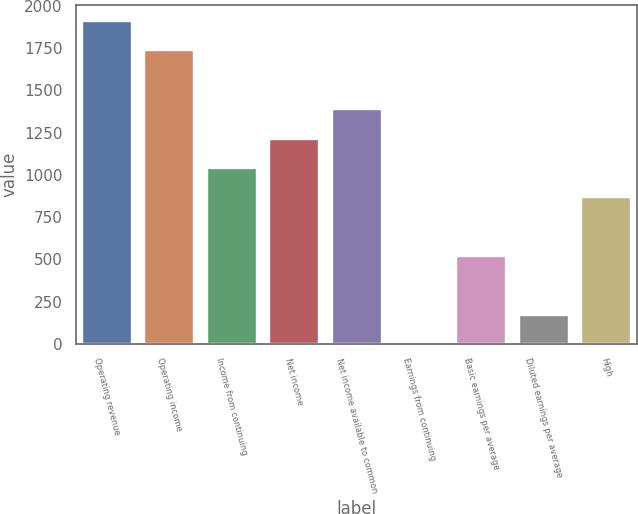<chart> <loc_0><loc_0><loc_500><loc_500><bar_chart><fcel>Operating revenue<fcel>Operating income<fcel>Income from continuing<fcel>Net income<fcel>Net income available to common<fcel>Earnings from continuing<fcel>Basic earnings per average<fcel>Diluted earnings per average<fcel>High<nl><fcel>1909.53<fcel>1735.97<fcel>1041.73<fcel>1215.29<fcel>1388.85<fcel>0.37<fcel>521.05<fcel>173.93<fcel>868.17<nl></chart> 